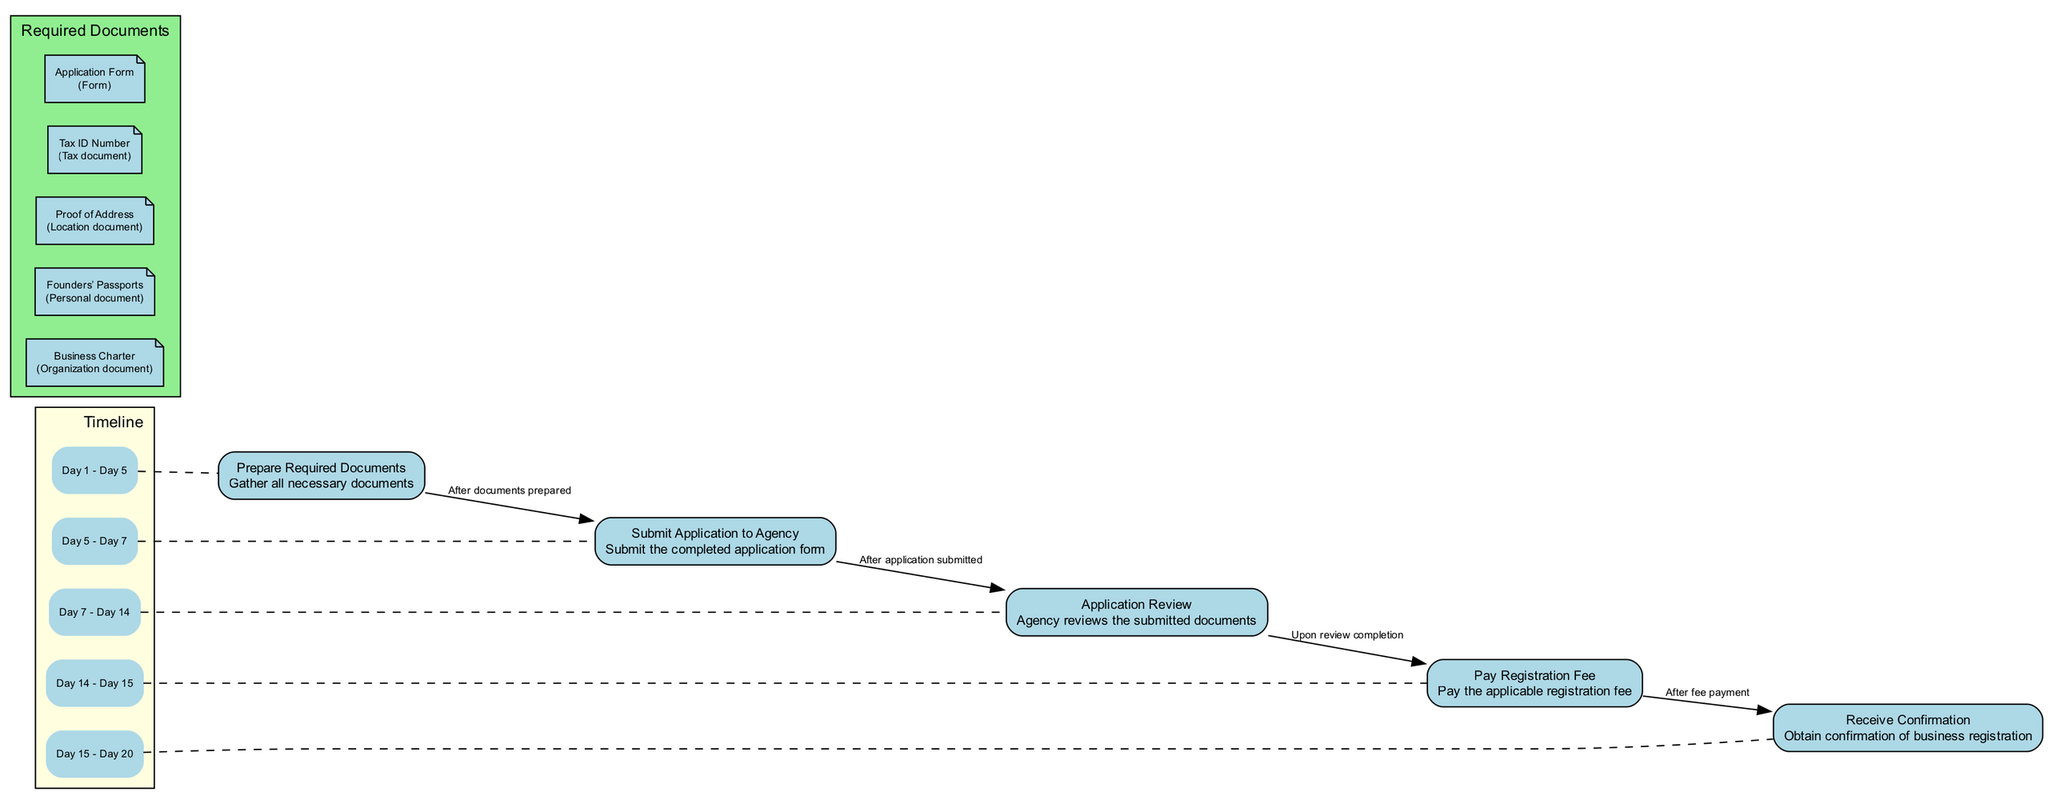What is the first step in the annual business registration process? The diagram lists "Prepare Required Documents" as the first step in the process. It’s clearly indicated at the beginning of the flow.
Answer: Prepare Required Documents How many steps are there in the diagram? The diagram includes five distinct steps in the annual business registration process, which can be counted directly from the nodes.
Answer: 5 What document verifies the business location? The diagram specifies "Proof of Address" as the document that verifies the business location. This is detailed under the required documents section.
Answer: Proof of Address What happens after the application is submitted? The flow shows that after the application is submitted, the next step is “Application Review,” which connects the two steps with an edge labeled "After application submitted."
Answer: Application Review On which day does the payment of the registration fee take place? According to the timeline in the diagram, the payment of the registration fee occurs on "Day 14" to "Day 15." This can be calculated from the timeline associated with the corresponding step.
Answer: Day 14 What is the relationship between "Pay Registration Fee" and "Receive Confirmation"? The relationship is that the payment must be completed before receiving confirmation, as indicated by the edge labeled "After fee payment" connecting these two steps.
Answer: After fee payment Which document is classified as a personal document? The diagram categorizes "Founders’ Passports" as a personal document, which is clearly labeled under the required documents section.
Answer: Founders’ Passports How long does the agency review applications? The timeline indicates that "Application Review" occurs from "Day 7" to "Day 14," which is a total of 7 days.
Answer: 7 days What is the last step in the registration process? The diagram indicates "Receive Confirmation" as the last step in the annual business registration process, concluding the flow of the steps involved.
Answer: Receive Confirmation 